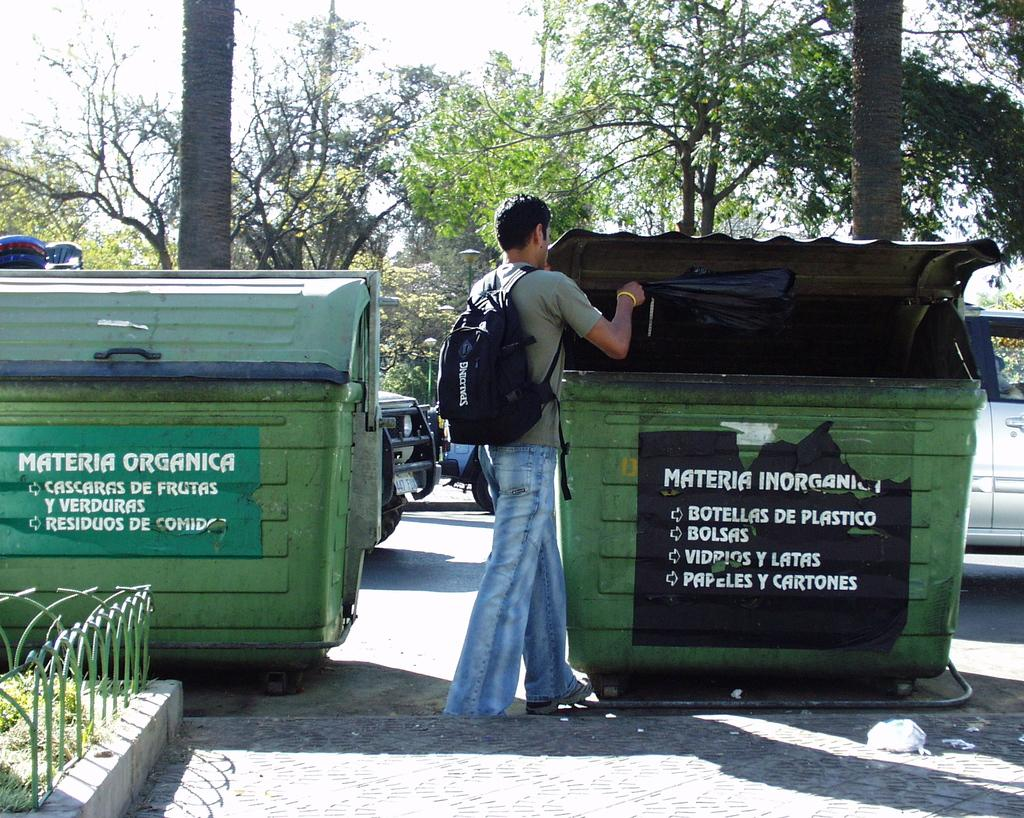<image>
Describe the image concisely. a man with a backpack next to a large object with the word materia on it 